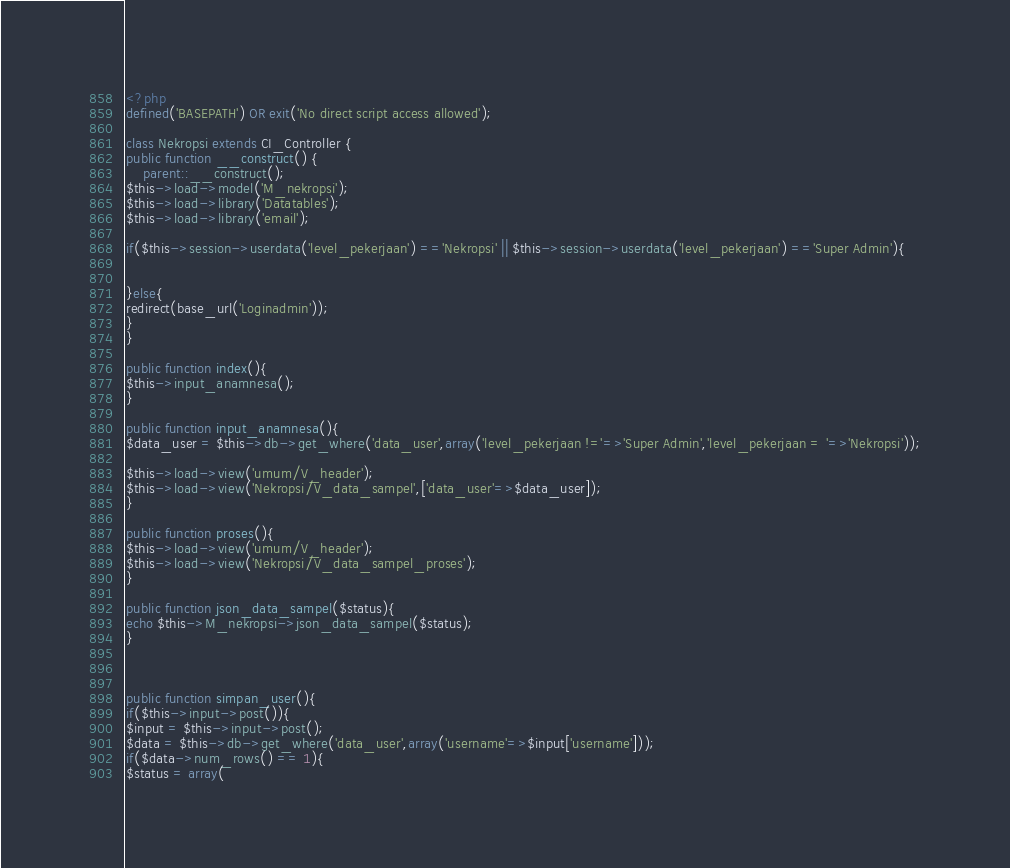<code> <loc_0><loc_0><loc_500><loc_500><_PHP_><?php
defined('BASEPATH') OR exit('No direct script access allowed');

class Nekropsi extends CI_Controller {
public function __construct() {
    parent::__construct();
$this->load->model('M_nekropsi');
$this->load->library('Datatables');
$this->load->library('email');

if($this->session->userdata('level_pekerjaan') =='Nekropsi' || $this->session->userdata('level_pekerjaan') =='Super Admin'){

    
}else{
redirect(base_url('Loginadmin'));        
}
}

public function index(){
$this->input_anamnesa();    
}

public function input_anamnesa(){
$data_user = $this->db->get_where('data_user',array('level_pekerjaan !='=>'Super Admin','level_pekerjaan = '=>'Nekropsi'));

$this->load->view('umum/V_header');
$this->load->view('Nekropsi/V_data_sampel',['data_user'=>$data_user]);    
}

public function proses(){
$this->load->view('umum/V_header');
$this->load->view('Nekropsi/V_data_sampel_proses');    
}

public function json_data_sampel($status){
echo $this->M_nekropsi->json_data_sampel($status);       
}



public function simpan_user(){
if($this->input->post()){
$input = $this->input->post();
$data = $this->db->get_where('data_user',array('username'=>$input['username']));
if($data->num_rows() == 1){
$status = array(</code> 